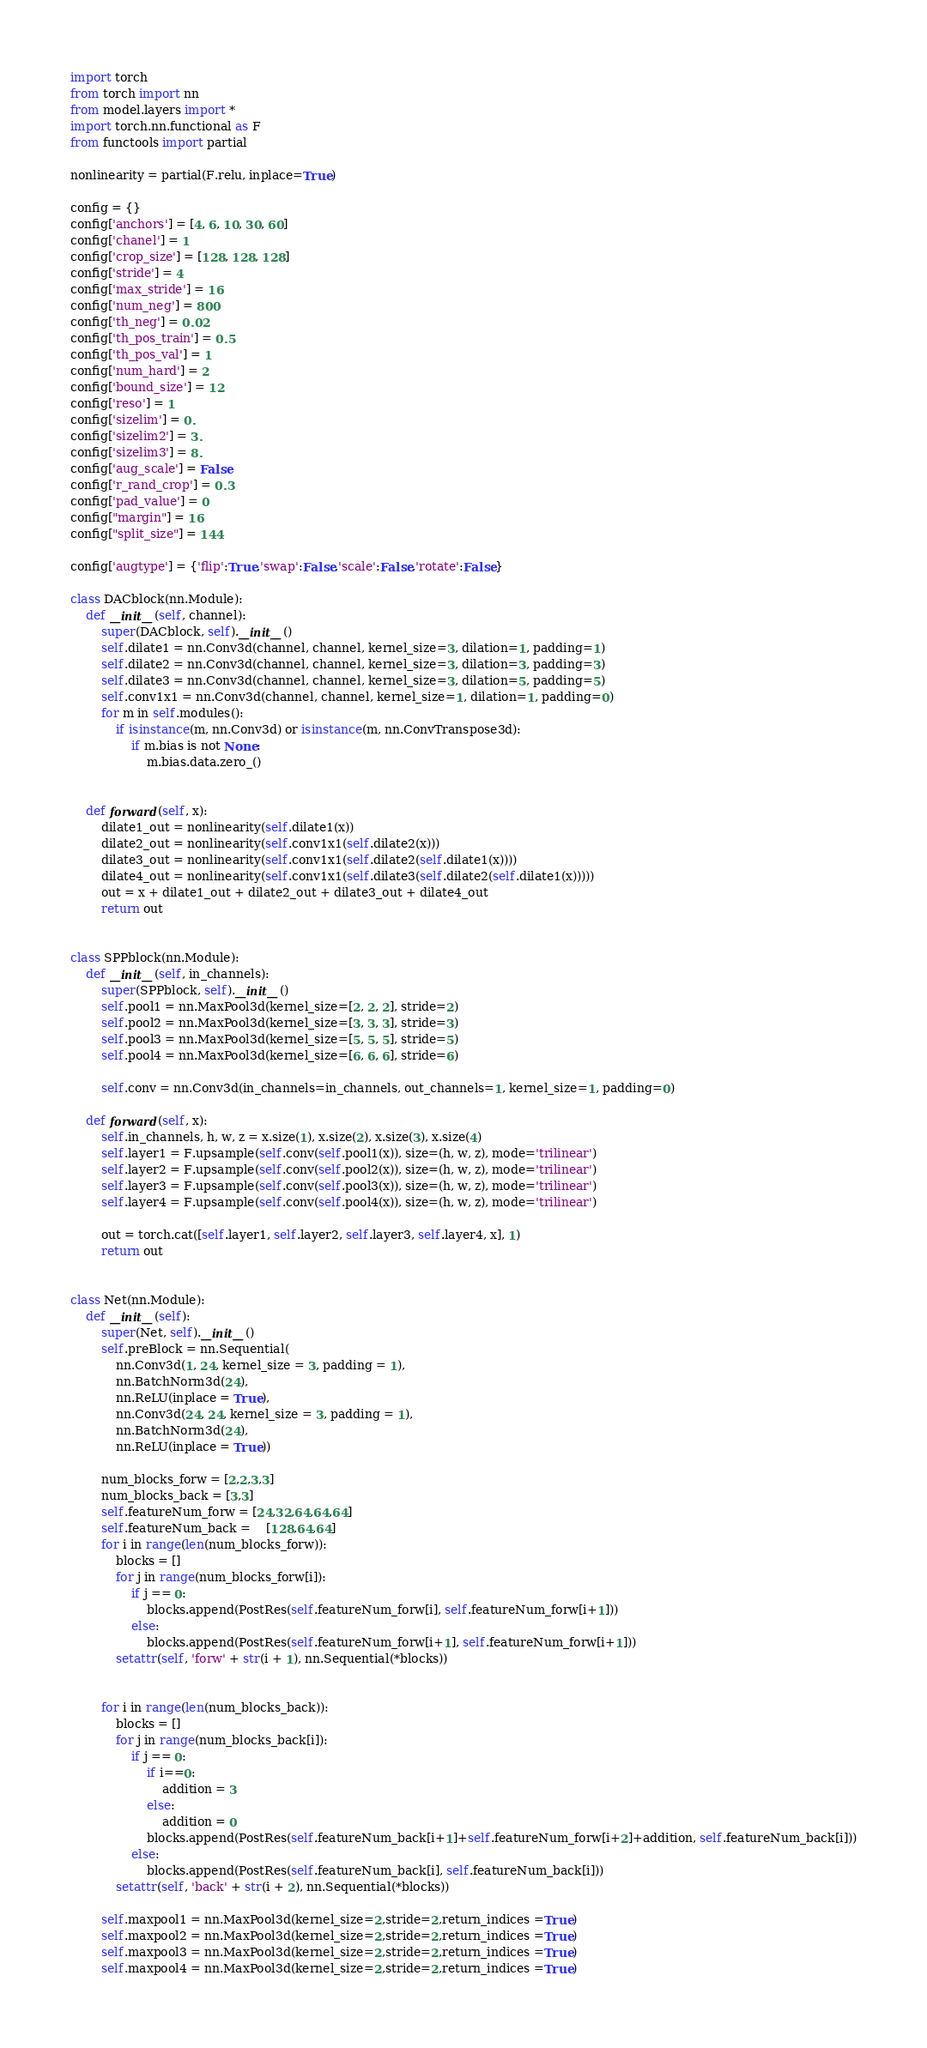<code> <loc_0><loc_0><loc_500><loc_500><_Python_>import torch
from torch import nn
from model.layers import *
import torch.nn.functional as F
from functools import partial

nonlinearity = partial(F.relu, inplace=True)

config = {}
config['anchors'] = [4, 6, 10, 30, 60]
config['chanel'] = 1
config['crop_size'] = [128, 128, 128]
config['stride'] = 4
config['max_stride'] = 16
config['num_neg'] = 800
config['th_neg'] = 0.02
config['th_pos_train'] = 0.5
config['th_pos_val'] = 1
config['num_hard'] = 2
config['bound_size'] = 12
config['reso'] = 1
config['sizelim'] = 0. 
config['sizelim2'] = 3.
config['sizelim3'] = 8.
config['aug_scale'] = False
config['r_rand_crop'] = 0.3
config['pad_value'] = 0
config["margin"] = 16
config["split_size"] = 144

config['augtype'] = {'flip':True,'swap':False,'scale':False,'rotate':False}

class DACblock(nn.Module):
    def __init__(self, channel):
        super(DACblock, self).__init__()
        self.dilate1 = nn.Conv3d(channel, channel, kernel_size=3, dilation=1, padding=1)
        self.dilate2 = nn.Conv3d(channel, channel, kernel_size=3, dilation=3, padding=3)
        self.dilate3 = nn.Conv3d(channel, channel, kernel_size=3, dilation=5, padding=5)
        self.conv1x1 = nn.Conv3d(channel, channel, kernel_size=1, dilation=1, padding=0)
        for m in self.modules():
            if isinstance(m, nn.Conv3d) or isinstance(m, nn.ConvTranspose3d):
                if m.bias is not None:
                    m.bias.data.zero_()


    def forward(self, x):
        dilate1_out = nonlinearity(self.dilate1(x))
        dilate2_out = nonlinearity(self.conv1x1(self.dilate2(x)))
        dilate3_out = nonlinearity(self.conv1x1(self.dilate2(self.dilate1(x))))
        dilate4_out = nonlinearity(self.conv1x1(self.dilate3(self.dilate2(self.dilate1(x)))))
        out = x + dilate1_out + dilate2_out + dilate3_out + dilate4_out
        return out


class SPPblock(nn.Module):
    def __init__(self, in_channels):
        super(SPPblock, self).__init__()
        self.pool1 = nn.MaxPool3d(kernel_size=[2, 2, 2], stride=2)
        self.pool2 = nn.MaxPool3d(kernel_size=[3, 3, 3], stride=3)
        self.pool3 = nn.MaxPool3d(kernel_size=[5, 5, 5], stride=5)
        self.pool4 = nn.MaxPool3d(kernel_size=[6, 6, 6], stride=6)

        self.conv = nn.Conv3d(in_channels=in_channels, out_channels=1, kernel_size=1, padding=0)

    def forward(self, x):
        self.in_channels, h, w, z = x.size(1), x.size(2), x.size(3), x.size(4)
        self.layer1 = F.upsample(self.conv(self.pool1(x)), size=(h, w, z), mode='trilinear')
        self.layer2 = F.upsample(self.conv(self.pool2(x)), size=(h, w, z), mode='trilinear')
        self.layer3 = F.upsample(self.conv(self.pool3(x)), size=(h, w, z), mode='trilinear')
        self.layer4 = F.upsample(self.conv(self.pool4(x)), size=(h, w, z), mode='trilinear')

        out = torch.cat([self.layer1, self.layer2, self.layer3, self.layer4, x], 1)
        return out


class Net(nn.Module):
    def __init__(self):
        super(Net, self).__init__()
        self.preBlock = nn.Sequential(
            nn.Conv3d(1, 24, kernel_size = 3, padding = 1),
            nn.BatchNorm3d(24),
            nn.ReLU(inplace = True),
            nn.Conv3d(24, 24, kernel_size = 3, padding = 1),
            nn.BatchNorm3d(24),
            nn.ReLU(inplace = True))
            
        num_blocks_forw = [2,2,3,3]
        num_blocks_back = [3,3]
        self.featureNum_forw = [24,32,64,64,64]
        self.featureNum_back =    [128,64,64]
        for i in range(len(num_blocks_forw)):
            blocks = []
            for j in range(num_blocks_forw[i]):
                if j == 0:
                    blocks.append(PostRes(self.featureNum_forw[i], self.featureNum_forw[i+1]))
                else:
                    blocks.append(PostRes(self.featureNum_forw[i+1], self.featureNum_forw[i+1]))
            setattr(self, 'forw' + str(i + 1), nn.Sequential(*blocks))


        for i in range(len(num_blocks_back)):
            blocks = []
            for j in range(num_blocks_back[i]):
                if j == 0:
                    if i==0:
                        addition = 3
                    else:
                        addition = 0
                    blocks.append(PostRes(self.featureNum_back[i+1]+self.featureNum_forw[i+2]+addition, self.featureNum_back[i]))
                else:
                    blocks.append(PostRes(self.featureNum_back[i], self.featureNum_back[i]))
            setattr(self, 'back' + str(i + 2), nn.Sequential(*blocks))

        self.maxpool1 = nn.MaxPool3d(kernel_size=2,stride=2,return_indices =True)
        self.maxpool2 = nn.MaxPool3d(kernel_size=2,stride=2,return_indices =True)
        self.maxpool3 = nn.MaxPool3d(kernel_size=2,stride=2,return_indices =True)
        self.maxpool4 = nn.MaxPool3d(kernel_size=2,stride=2,return_indices =True)</code> 